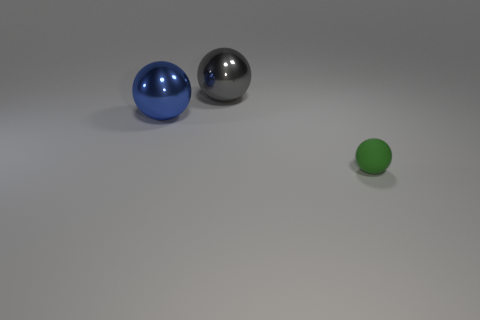Add 2 metallic spheres. How many objects exist? 5 Add 3 gray metallic balls. How many gray metallic balls exist? 4 Subtract 0 cyan blocks. How many objects are left? 3 Subtract all green things. Subtract all green rubber objects. How many objects are left? 1 Add 1 blue things. How many blue things are left? 2 